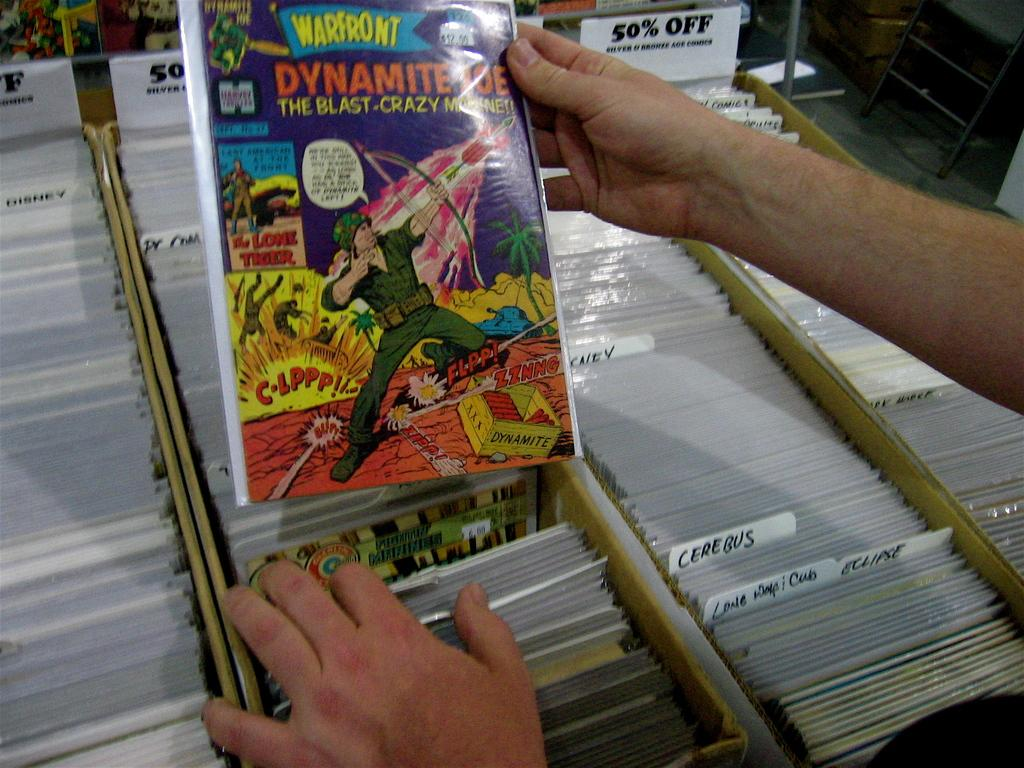<image>
Share a concise interpretation of the image provided. A man holds a Warfront comic above a box. 